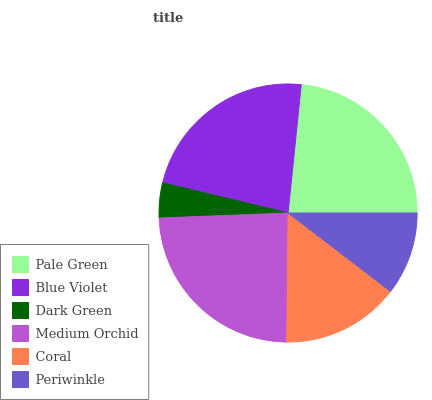Is Dark Green the minimum?
Answer yes or no. Yes. Is Medium Orchid the maximum?
Answer yes or no. Yes. Is Blue Violet the minimum?
Answer yes or no. No. Is Blue Violet the maximum?
Answer yes or no. No. Is Pale Green greater than Blue Violet?
Answer yes or no. Yes. Is Blue Violet less than Pale Green?
Answer yes or no. Yes. Is Blue Violet greater than Pale Green?
Answer yes or no. No. Is Pale Green less than Blue Violet?
Answer yes or no. No. Is Blue Violet the high median?
Answer yes or no. Yes. Is Coral the low median?
Answer yes or no. Yes. Is Dark Green the high median?
Answer yes or no. No. Is Blue Violet the low median?
Answer yes or no. No. 